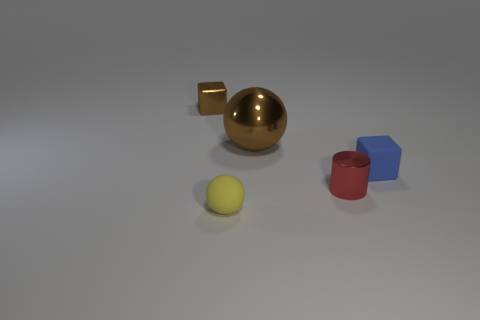What number of other objects are there of the same material as the tiny red object?
Your answer should be very brief. 2. What number of brown metallic spheres are behind the tiny block to the right of the red shiny cylinder?
Offer a terse response. 1. How many cubes are blue matte objects or small brown metal objects?
Your answer should be compact. 2. The object that is right of the yellow thing and to the left of the small red thing is what color?
Offer a terse response. Brown. Is there any other thing that has the same color as the tiny sphere?
Offer a terse response. No. What is the color of the small metallic thing that is behind the matte object that is behind the tiny yellow sphere?
Offer a very short reply. Brown. Is the red shiny thing the same size as the matte block?
Offer a terse response. Yes. Is the material of the sphere in front of the tiny blue rubber thing the same as the brown thing on the right side of the small brown metallic thing?
Ensure brevity in your answer.  No. There is a brown shiny object that is on the right side of the cube that is behind the cube on the right side of the tiny brown block; what shape is it?
Give a very brief answer. Sphere. Are there more cubes than purple things?
Provide a short and direct response. Yes. 